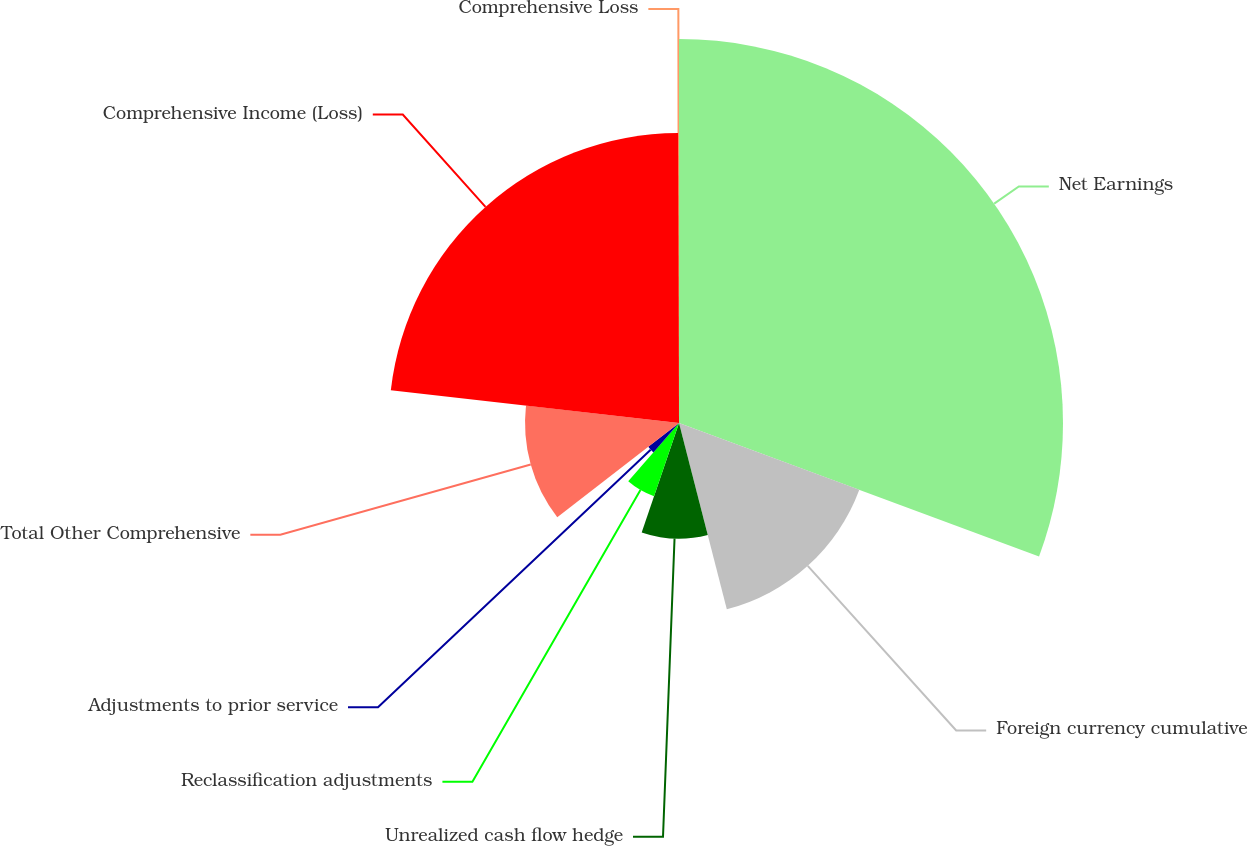Convert chart. <chart><loc_0><loc_0><loc_500><loc_500><pie_chart><fcel>Net Earnings<fcel>Foreign currency cumulative<fcel>Unrealized cash flow hedge<fcel>Reclassification adjustments<fcel>Adjustments to prior service<fcel>Total Other Comprehensive<fcel>Comprehensive Income (Loss)<fcel>Comprehensive Loss<nl><fcel>30.65%<fcel>15.35%<fcel>9.23%<fcel>6.17%<fcel>3.11%<fcel>12.29%<fcel>23.15%<fcel>0.05%<nl></chart> 